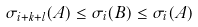<formula> <loc_0><loc_0><loc_500><loc_500>\sigma _ { i + k + l } ( A ) \leq \sigma _ { i } ( B ) \leq \sigma _ { i } ( A )</formula> 